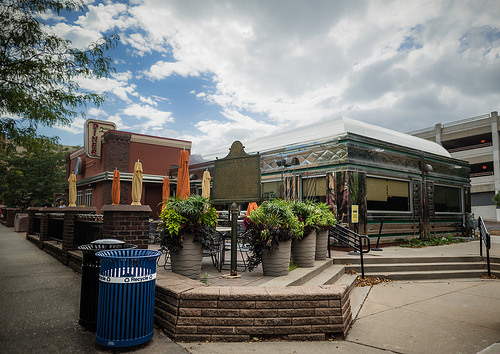<image>
Is there a plant behind the garbage can? Yes. From this viewpoint, the plant is positioned behind the garbage can, with the garbage can partially or fully occluding the plant. 